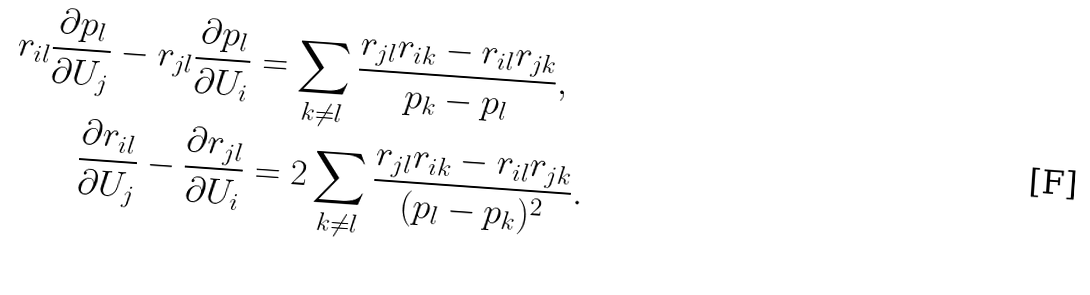Convert formula to latex. <formula><loc_0><loc_0><loc_500><loc_500>r _ { i l } \frac { \partial p _ { l } } { \partial U _ { j } } - r _ { j l } \frac { \partial p _ { l } } { \partial U _ { i } } & = \sum _ { k \neq l } \frac { r _ { j l } r _ { i k } - r _ { i l } r _ { j k } } { p _ { k } - p _ { l } } , \\ \frac { \partial r _ { i l } } { \partial U _ { j } } - \frac { \partial r _ { j l } } { \partial U _ { i } } & = 2 \sum _ { k \neq l } \frac { r _ { j l } r _ { i k } - r _ { i l } r _ { j k } } { ( p _ { l } - p _ { k } ) ^ { 2 } } .</formula> 